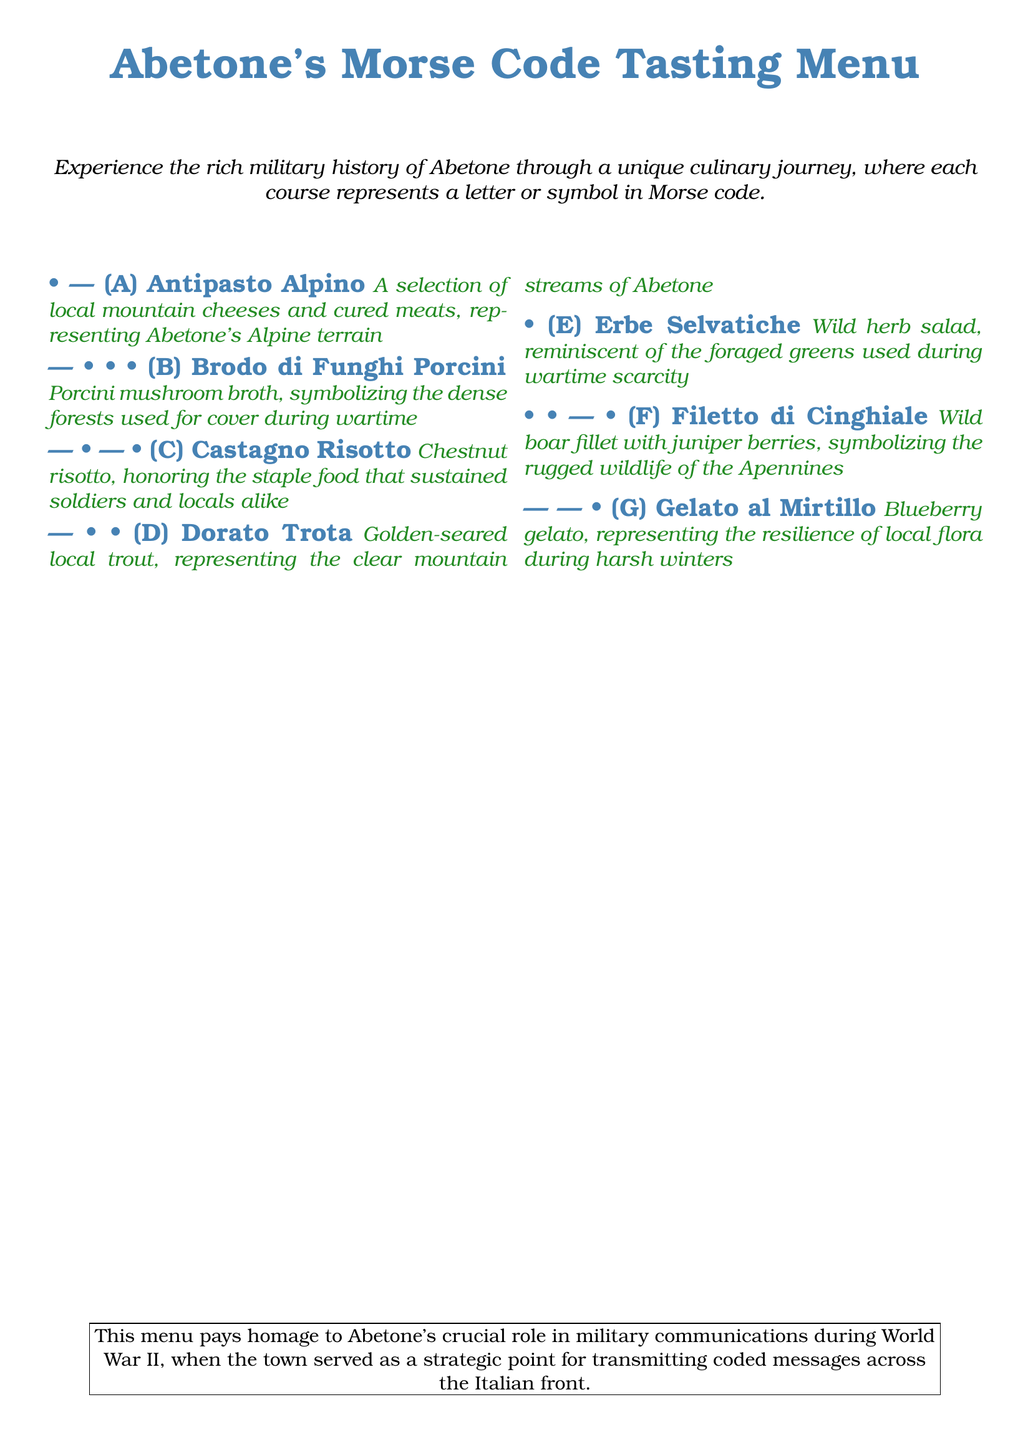What is the name of the tasting menu? The title of the tasting menu is provided at the top of the document.
Answer: Abetone's Morse Code Tasting Menu How many courses are in the menu? The menu includes a list of courses, which can be counted from the document.
Answer: 7 What does the "D" course represent? The document describes each course with letters, and "D" is associated with a specific dish.
Answer: Dorato Trota Which dish symbolizes the clear mountain streams of Abetone? The description under the "D" course gives details about a specific dish that represents the streams.
Answer: Golden-seared local trout What does the "C" course honor? The information provided under the "C" course explains what it represents.
Answer: The staple food that sustained soldiers and locals alike What is the significance of the blueberry gelato? The document states a specific aspect of local flora that the "G" course represents.
Answer: Resilience of local flora during harsh winters For which war does the menu pay homage to Abetone's role? The last section of the document notes the historical context related to the menu.
Answer: World War II 